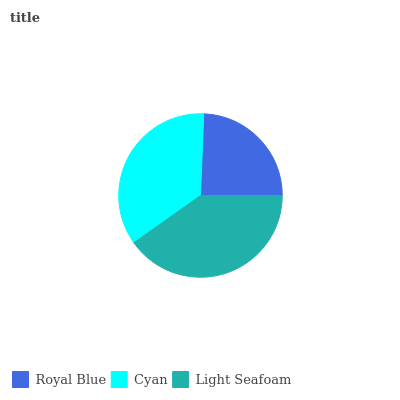Is Royal Blue the minimum?
Answer yes or no. Yes. Is Light Seafoam the maximum?
Answer yes or no. Yes. Is Cyan the minimum?
Answer yes or no. No. Is Cyan the maximum?
Answer yes or no. No. Is Cyan greater than Royal Blue?
Answer yes or no. Yes. Is Royal Blue less than Cyan?
Answer yes or no. Yes. Is Royal Blue greater than Cyan?
Answer yes or no. No. Is Cyan less than Royal Blue?
Answer yes or no. No. Is Cyan the high median?
Answer yes or no. Yes. Is Cyan the low median?
Answer yes or no. Yes. Is Royal Blue the high median?
Answer yes or no. No. Is Royal Blue the low median?
Answer yes or no. No. 